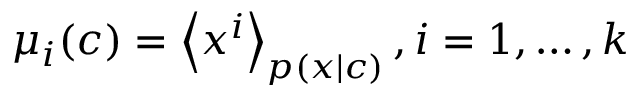Convert formula to latex. <formula><loc_0><loc_0><loc_500><loc_500>\mu _ { i } ( c ) = \left \langle x ^ { i } \right \rangle _ { p ( x | c ) } , i = 1 , \dots , k</formula> 